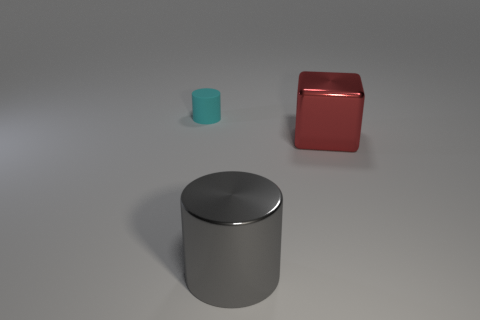Are there any other things that are the same shape as the large red object?
Ensure brevity in your answer.  No. Do the small cyan cylinder and the big thing that is behind the large gray metal object have the same material?
Give a very brief answer. No. The object that is behind the large cylinder and on the left side of the red metallic cube is what color?
Keep it short and to the point. Cyan. How many cylinders are gray shiny objects or small objects?
Offer a terse response. 2. There is a tiny cyan thing; is it the same shape as the object that is in front of the shiny block?
Your response must be concise. Yes. There is a object that is behind the large gray object and in front of the small matte cylinder; what size is it?
Your answer should be compact. Large. The big gray metal object has what shape?
Keep it short and to the point. Cylinder. There is a cylinder that is in front of the red thing; are there any large objects that are behind it?
Give a very brief answer. Yes. There is a cylinder in front of the small cyan cylinder; how many objects are behind it?
Keep it short and to the point. 2. What is the material of the gray object that is the same size as the red thing?
Your answer should be compact. Metal. 